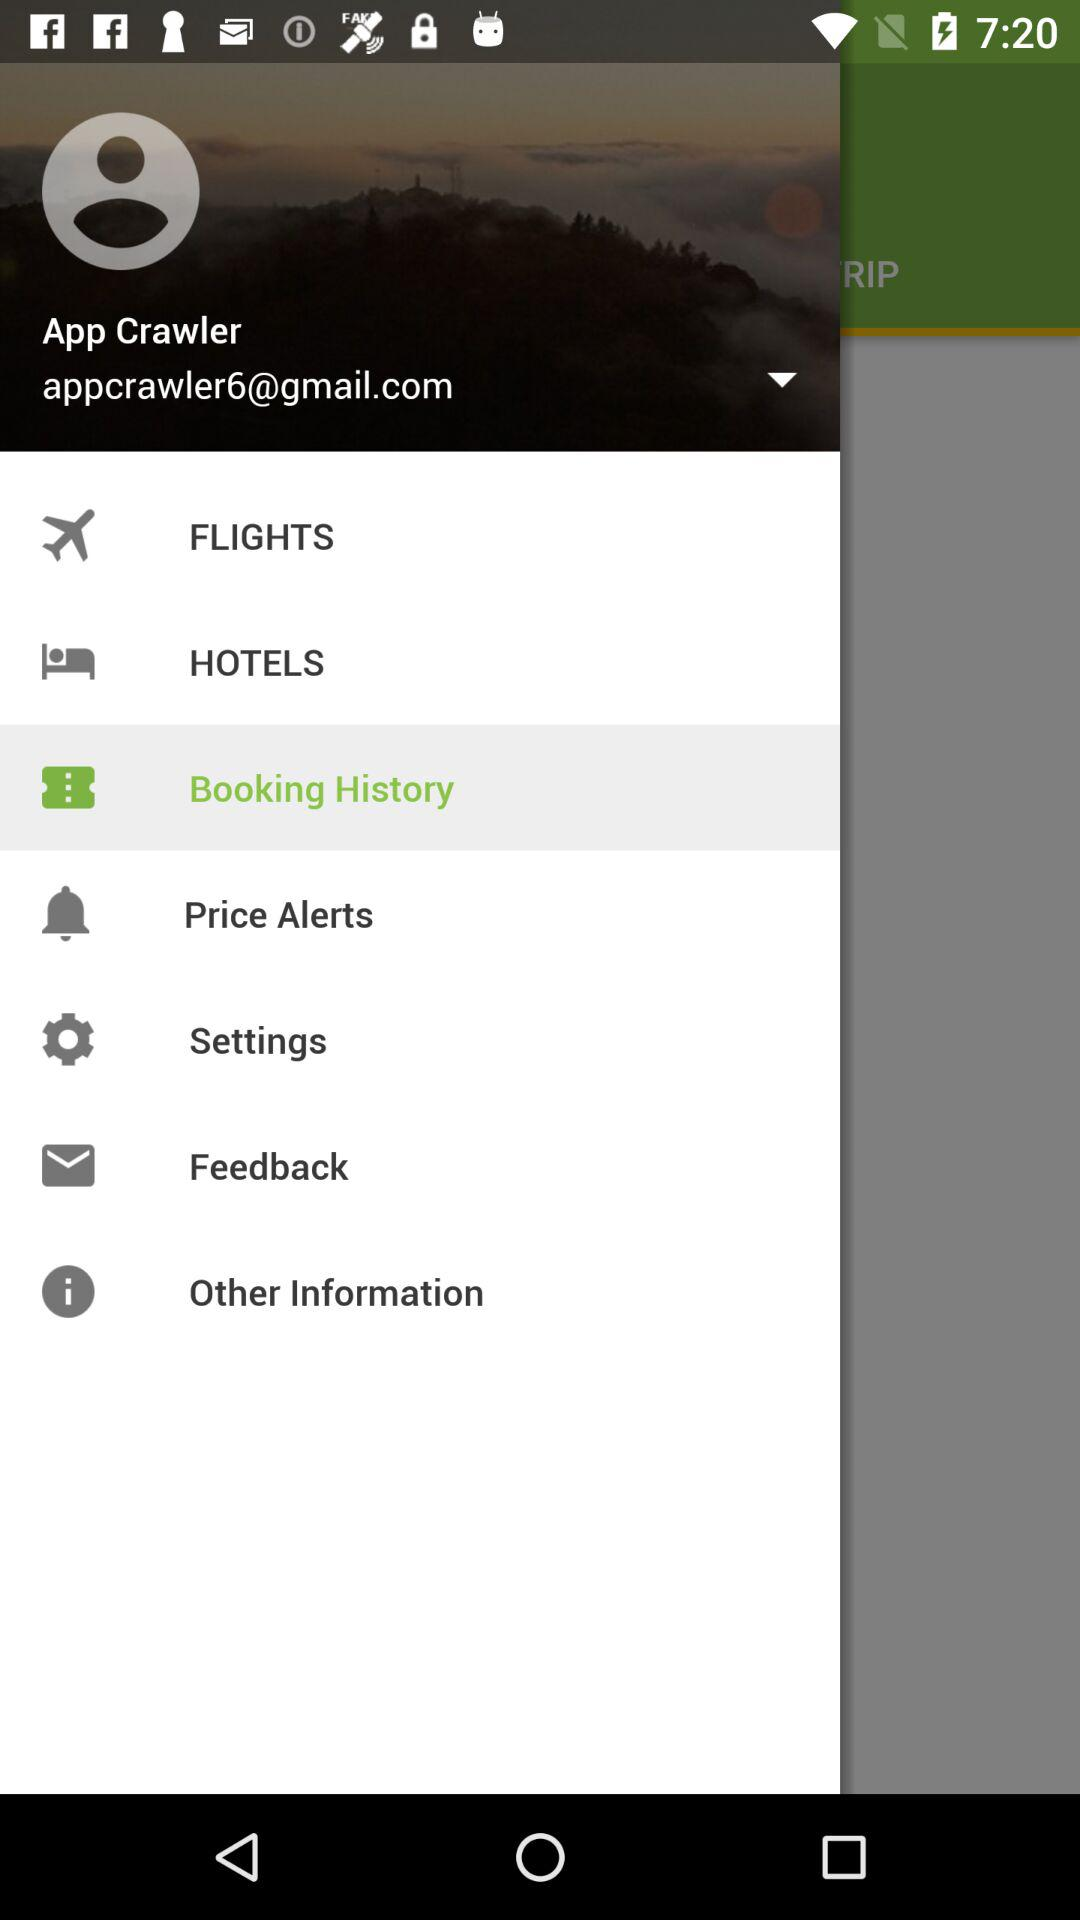What is the email address? The email address is appcrawler6@gmail.com. 